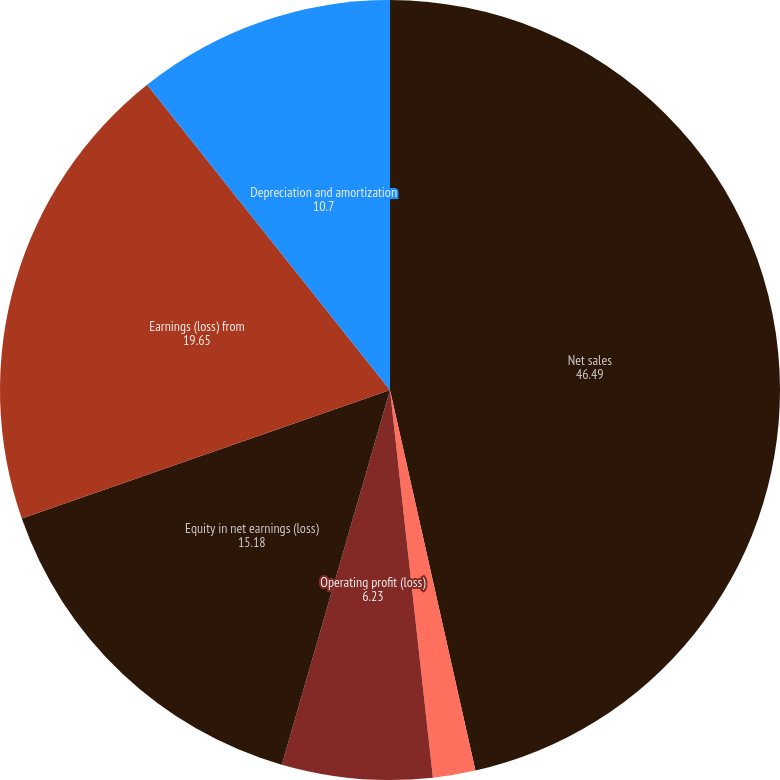<chart> <loc_0><loc_0><loc_500><loc_500><pie_chart><fcel>Net sales<fcel>Other (charges) gains net<fcel>Operating profit (loss)<fcel>Equity in net earnings (loss)<fcel>Earnings (loss) from<fcel>Depreciation and amortization<nl><fcel>46.49%<fcel>1.76%<fcel>6.23%<fcel>15.18%<fcel>19.65%<fcel>10.7%<nl></chart> 